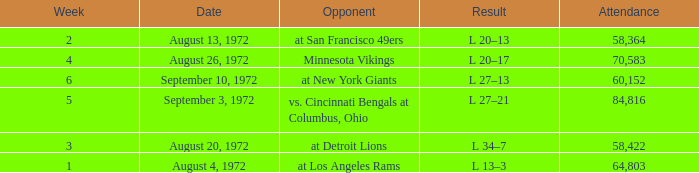How many weeks had an attendance larger than 84,816? 0.0. Would you mind parsing the complete table? {'header': ['Week', 'Date', 'Opponent', 'Result', 'Attendance'], 'rows': [['2', 'August 13, 1972', 'at San Francisco 49ers', 'L 20–13', '58,364'], ['4', 'August 26, 1972', 'Minnesota Vikings', 'L 20–17', '70,583'], ['6', 'September 10, 1972', 'at New York Giants', 'L 27–13', '60,152'], ['5', 'September 3, 1972', 'vs. Cincinnati Bengals at Columbus, Ohio', 'L 27–21', '84,816'], ['3', 'August 20, 1972', 'at Detroit Lions', 'L 34–7', '58,422'], ['1', 'August 4, 1972', 'at Los Angeles Rams', 'L 13–3', '64,803']]} 